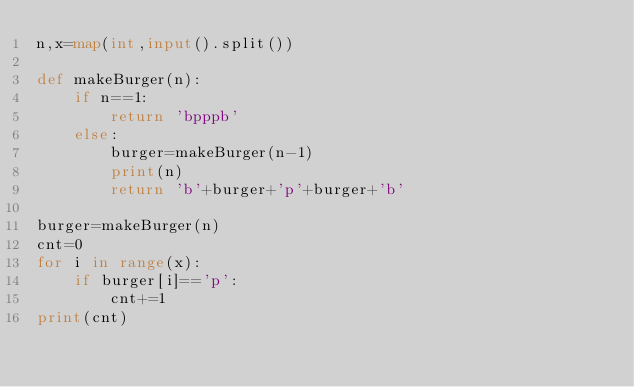<code> <loc_0><loc_0><loc_500><loc_500><_Python_>n,x=map(int,input().split())

def makeBurger(n):
    if n==1:
        return 'bpppb'
    else:
        burger=makeBurger(n-1)
        print(n)
        return 'b'+burger+'p'+burger+'b'

burger=makeBurger(n)
cnt=0
for i in range(x):
    if burger[i]=='p':
        cnt+=1
print(cnt)</code> 